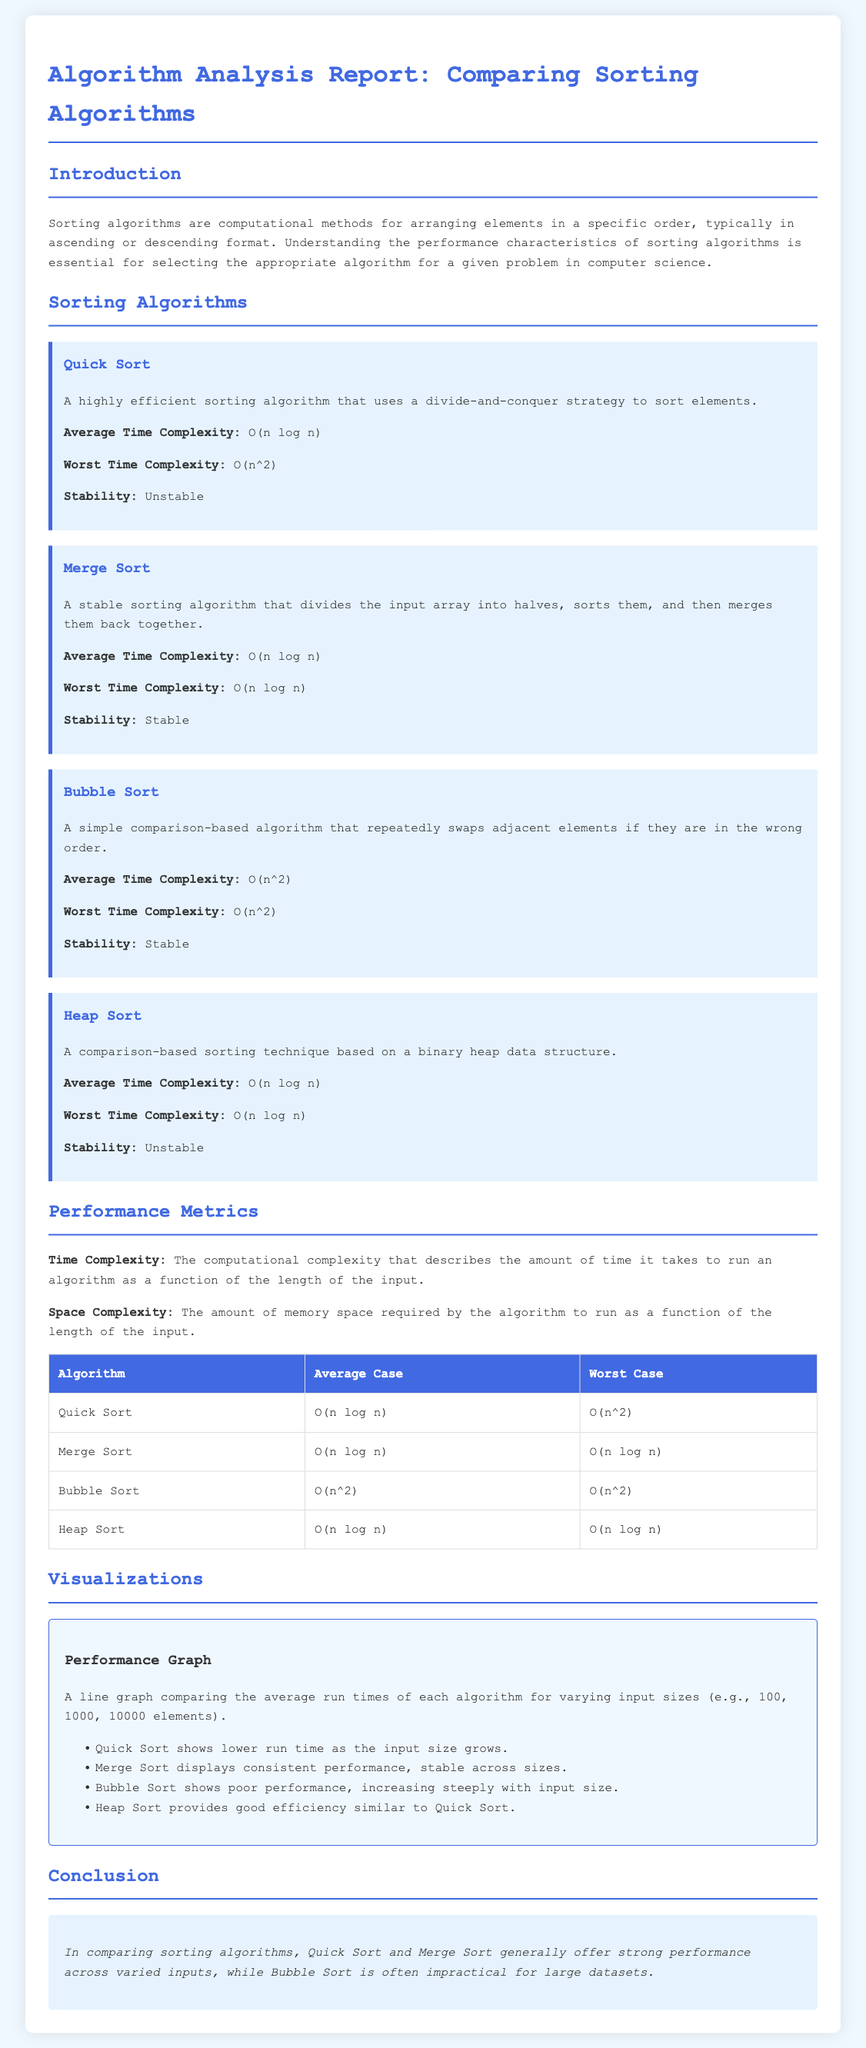What is the average time complexity of Quick Sort? The average time complexity of Quick Sort, as stated in the report, is O(n log n).
Answer: O(n log n) What is the stability of Merge Sort? The report indicates that Merge Sort is a stable sorting algorithm.
Answer: Stable Which sorting algorithm has the worst time complexity of O(n^2)? According to the document, both Quick Sort and Bubble Sort have this worst-case time complexity.
Answer: Bubble Sort How does Bubble Sort perform as input size increases? The visualization section describes Bubble Sort as showing poor performance, increasing steeply with input size.
Answer: Poor performance Which two sorting algorithms offer strong performance across varied inputs? The conclusion highlights Quick Sort and Merge Sort as offering strong performance.
Answer: Quick Sort and Merge Sort What is the worst time complexity of Heap Sort? The report specifies that the worst time complexity of Heap Sort is O(n log n).
Answer: O(n log n) What type of graph is used in the visualization section? The document mentions a line graph comparing the average run times.
Answer: Line graph What does the performance graph indicate about Quick Sort's run time? The visualization notes that Quick Sort shows lower run time as the input size grows.
Answer: Lower run time 